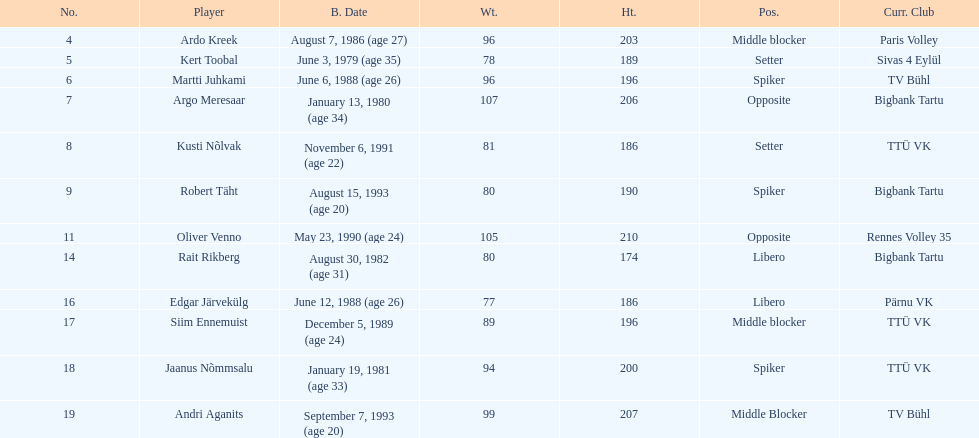Which player is taller than andri agantis? Oliver Venno. 